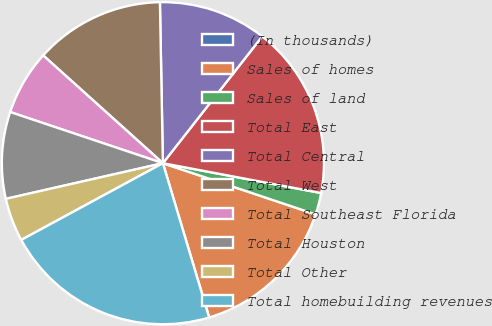Convert chart. <chart><loc_0><loc_0><loc_500><loc_500><pie_chart><fcel>(In thousands)<fcel>Sales of homes<fcel>Sales of land<fcel>Total East<fcel>Total Central<fcel>Total West<fcel>Total Southeast Florida<fcel>Total Houston<fcel>Total Other<fcel>Total homebuilding revenues<nl><fcel>0.01%<fcel>15.21%<fcel>2.18%<fcel>17.39%<fcel>10.87%<fcel>13.04%<fcel>6.52%<fcel>8.7%<fcel>4.35%<fcel>21.73%<nl></chart> 